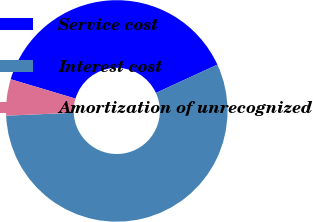Convert chart. <chart><loc_0><loc_0><loc_500><loc_500><pie_chart><fcel>Service cost<fcel>Interest cost<fcel>Amortization of unrecognized<nl><fcel>38.52%<fcel>56.18%<fcel>5.3%<nl></chart> 